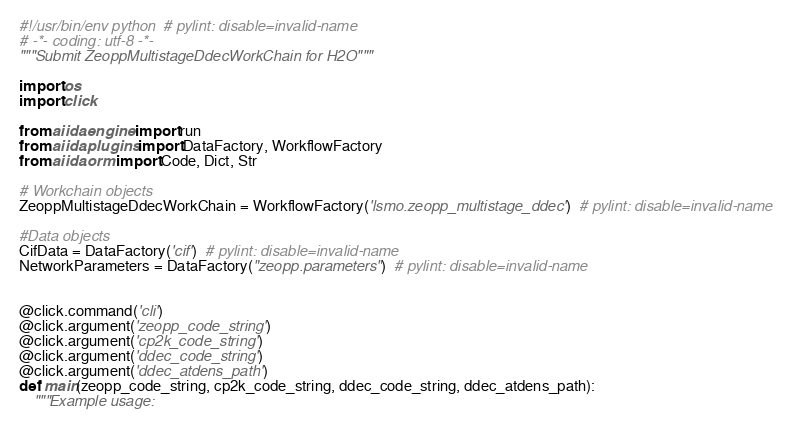<code> <loc_0><loc_0><loc_500><loc_500><_Python_>#!/usr/bin/env python  # pylint: disable=invalid-name
# -*- coding: utf-8 -*-
"""Submit ZeoppMultistageDdecWorkChain for H2O"""

import os
import click

from aiida.engine import run
from aiida.plugins import DataFactory, WorkflowFactory
from aiida.orm import Code, Dict, Str

# Workchain objects
ZeoppMultistageDdecWorkChain = WorkflowFactory('lsmo.zeopp_multistage_ddec')  # pylint: disable=invalid-name

#Data objects
CifData = DataFactory('cif')  # pylint: disable=invalid-name
NetworkParameters = DataFactory("zeopp.parameters")  # pylint: disable=invalid-name


@click.command('cli')
@click.argument('zeopp_code_string')
@click.argument('cp2k_code_string')
@click.argument('ddec_code_string')
@click.argument('ddec_atdens_path')
def main(zeopp_code_string, cp2k_code_string, ddec_code_string, ddec_atdens_path):
    """Example usage:</code> 